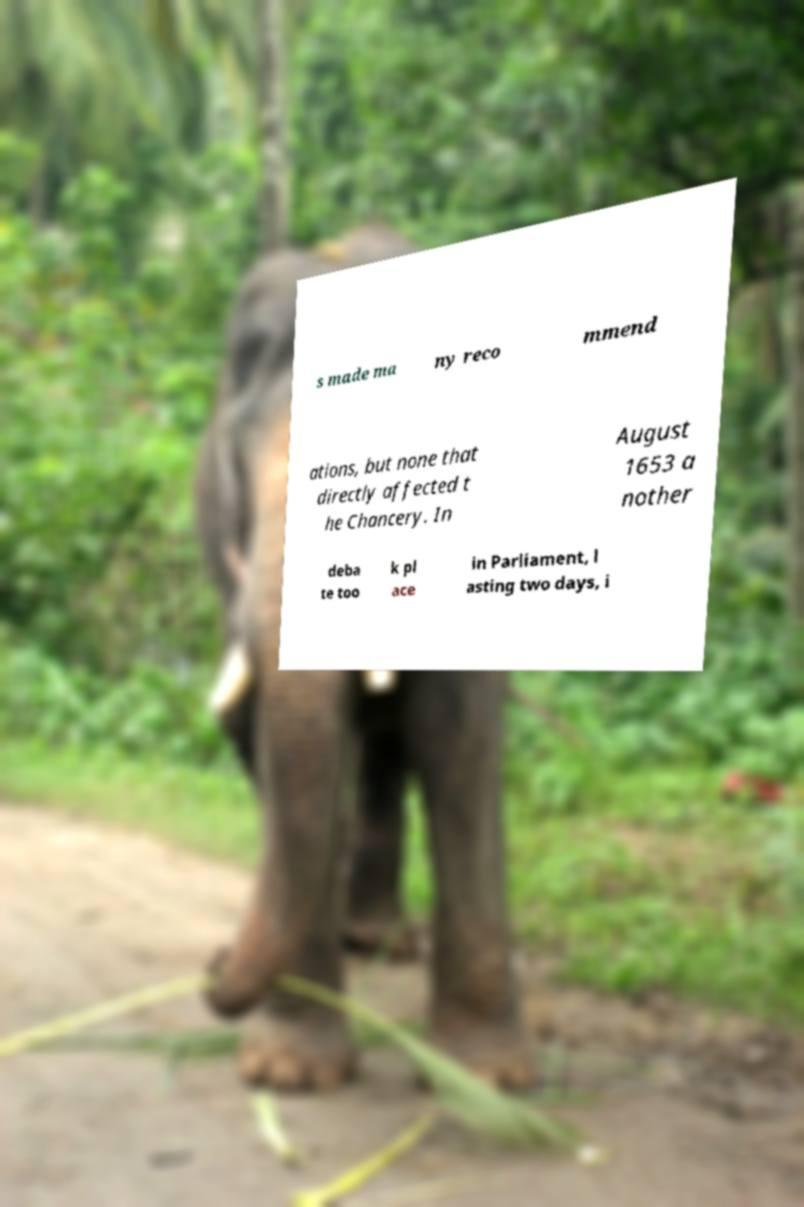Please read and relay the text visible in this image. What does it say? s made ma ny reco mmend ations, but none that directly affected t he Chancery. In August 1653 a nother deba te too k pl ace in Parliament, l asting two days, i 